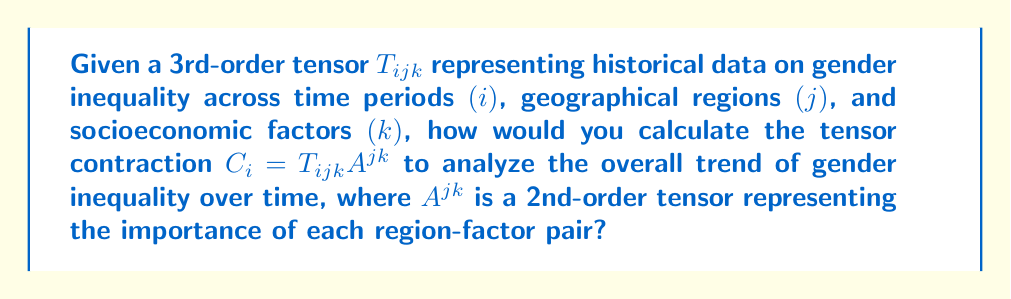Can you answer this question? To calculate the tensor contraction $C_{i} = T_{ijk}A^{jk}$, we follow these steps:

1. Understand the dimensions:
   - $T_{ijk}$: 3rd-order tensor (time periods × regions × factors)
   - $A^{jk}$: 2nd-order tensor (regions × factors)
   - $C_{i}$: 1st-order tensor (vector) of time periods

2. Apply the Einstein summation convention:
   $$C_{i} = \sum_{j=1}^{J} \sum_{k=1}^{K} T_{ijk}A^{jk}$$
   Where $J$ is the number of regions and $K$ is the number of factors.

3. For each time period $i$:
   a. Multiply each element of $T_{ijk}$ with the corresponding element of $A^{jk}$
   b. Sum all these products over $j$ and $k$ indices

4. The resulting $C_{i}$ represents the weighted sum of gender inequality data for each time period, considering the importance of each region-factor pair.

5. Analyze $C_{i}$ to observe trends:
   - Increasing values indicate worsening gender inequality over time
   - Decreasing values suggest improving gender equality
   - Constant values imply stagnation in gender equality efforts

This contraction allows for a comprehensive analysis of gender inequality trends, accounting for regional and socioeconomic variations, which aligns with the persona's focus on women's history and challenging traditional interpretations.
Answer: $C_{i} = \sum_{j=1}^{J} \sum_{k=1}^{K} T_{ijk}A^{jk}$ 